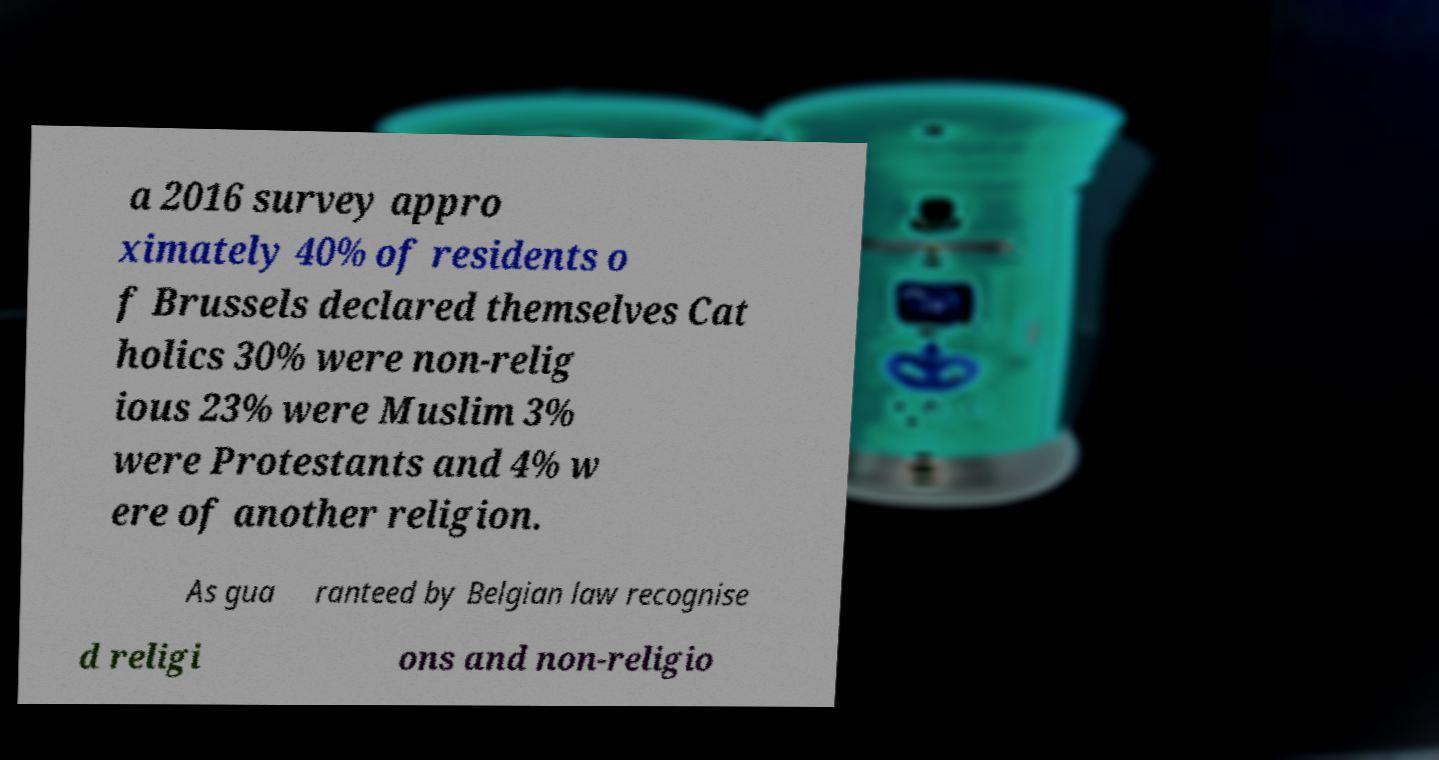Could you extract and type out the text from this image? a 2016 survey appro ximately 40% of residents o f Brussels declared themselves Cat holics 30% were non-relig ious 23% were Muslim 3% were Protestants and 4% w ere of another religion. As gua ranteed by Belgian law recognise d religi ons and non-religio 